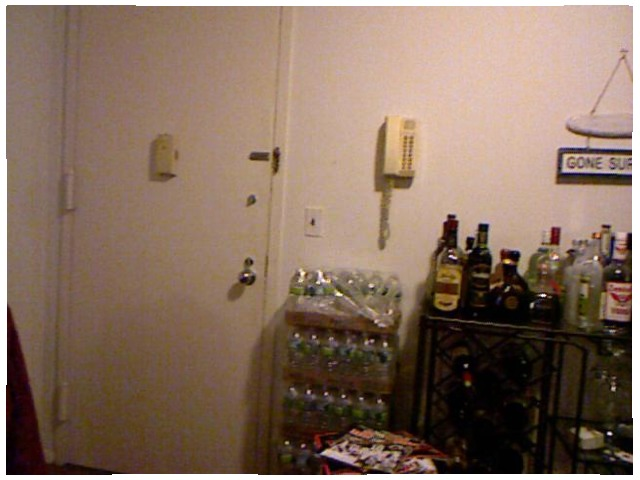<image>
Is there a phone on the wall? Yes. Looking at the image, I can see the phone is positioned on top of the wall, with the wall providing support. Where is the liquor in relation to the water? Is it to the left of the water? No. The liquor is not to the left of the water. From this viewpoint, they have a different horizontal relationship. Is there a phone to the right of the door? Yes. From this viewpoint, the phone is positioned to the right side relative to the door. Where is the alchoholic drinks in relation to the telephone? Is it next to the telephone? Yes. The alchoholic drinks is positioned adjacent to the telephone, located nearby in the same general area. 